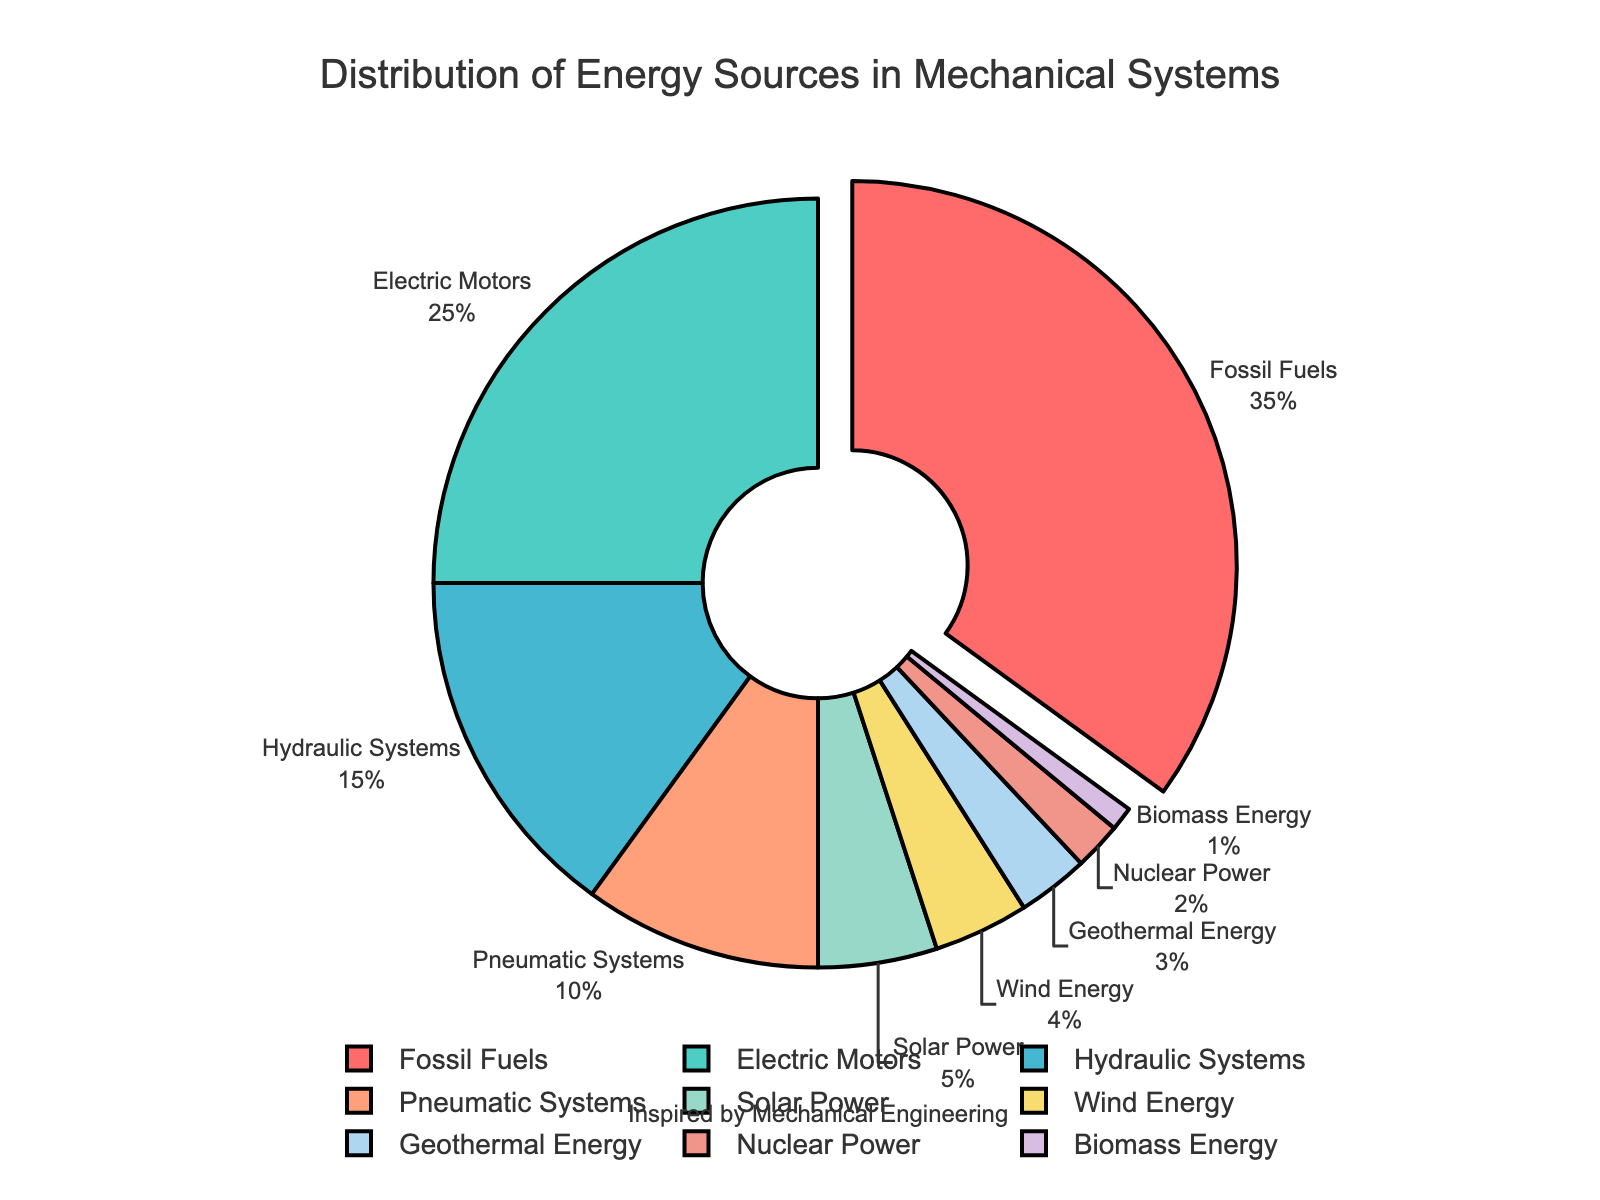What percentage of mechanical systems utilize pneumatic systems? Locate the segment labeled "Pneumatic Systems" on the pie chart. The associated percentage value is displayed alongside it.
Answer: 10% What is the combined percentage of renewable energy sources? Identify the segments for Solar Power, Wind Energy, Geothermal Energy, and Biomass Energy. Add their percentages: 5% (Solar Power) + 4% (Wind Energy) + 3% (Geothermal Energy) + 1% (Biomass Energy) = 13%.
Answer: 13% Which energy source is the most utilized in mechanical systems? Identify the segment that stands out with the highest percentage. The slice pulled out from the chart highlights this, which is labeled "Fossil Fuels" with a percentage of 35%.
Answer: Fossil Fuels How much more do fossil fuels contribute compared to electric motors in mechanical systems? Identify the segments labeled "Fossil Fuels" (35%) and "Electric Motors" (25%). Subtract the smaller percentage from the larger one: 35% - 25% = 10%.
Answer: 10% What color is associated with the segment representing hydraulic systems in the chart? Look for the segment labeled "Hydraulic Systems" and note its color. The hydraulic systems segment is marked in a color halfway between green and blue.
Answer: Light blue Is nuclear power a major or minor contributor in terms of percentage? Locate the segment labeled "Nuclear Power" and check its percentage, which is 2%. Since it's quite low compared to other segments, it is a minor contributor.
Answer: Minor 